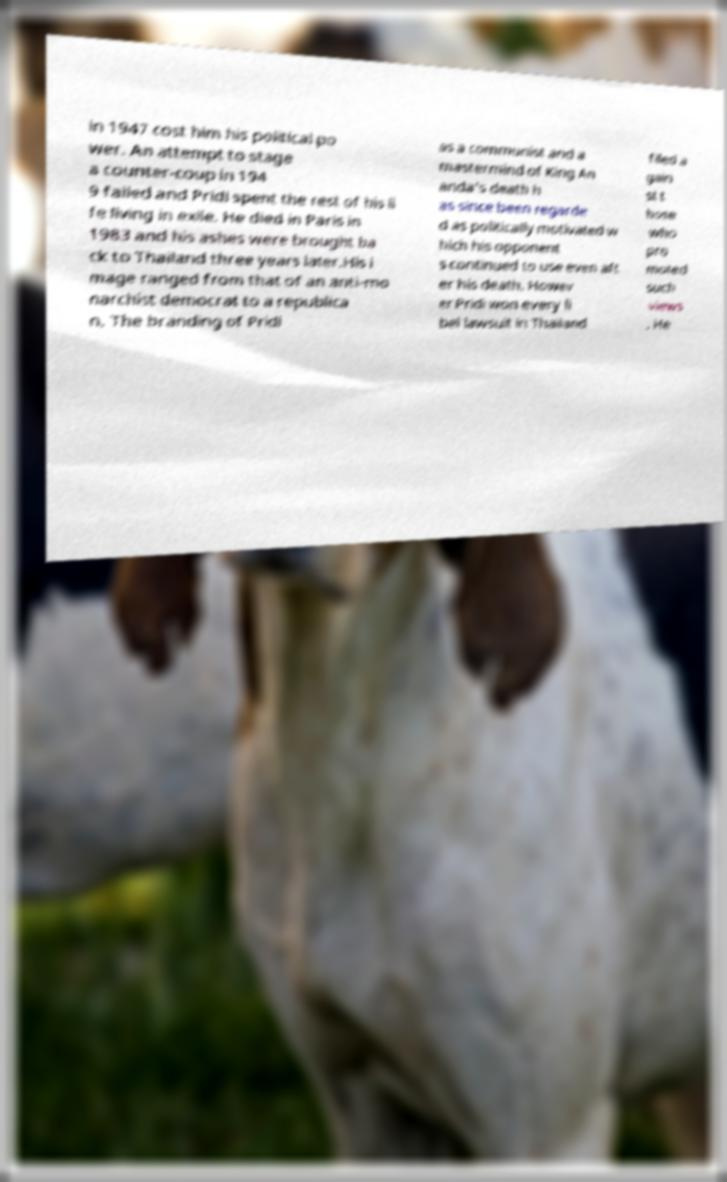There's text embedded in this image that I need extracted. Can you transcribe it verbatim? in 1947 cost him his political po wer. An attempt to stage a counter-coup in 194 9 failed and Pridi spent the rest of his li fe living in exile. He died in Paris in 1983 and his ashes were brought ba ck to Thailand three years later.His i mage ranged from that of an anti-mo narchist democrat to a republica n. The branding of Pridi as a communist and a mastermind of King An anda's death h as since been regarde d as politically motivated w hich his opponent s continued to use even aft er his death. Howev er Pridi won every li bel lawsuit in Thailand filed a gain st t hose who pro moted such views . He 